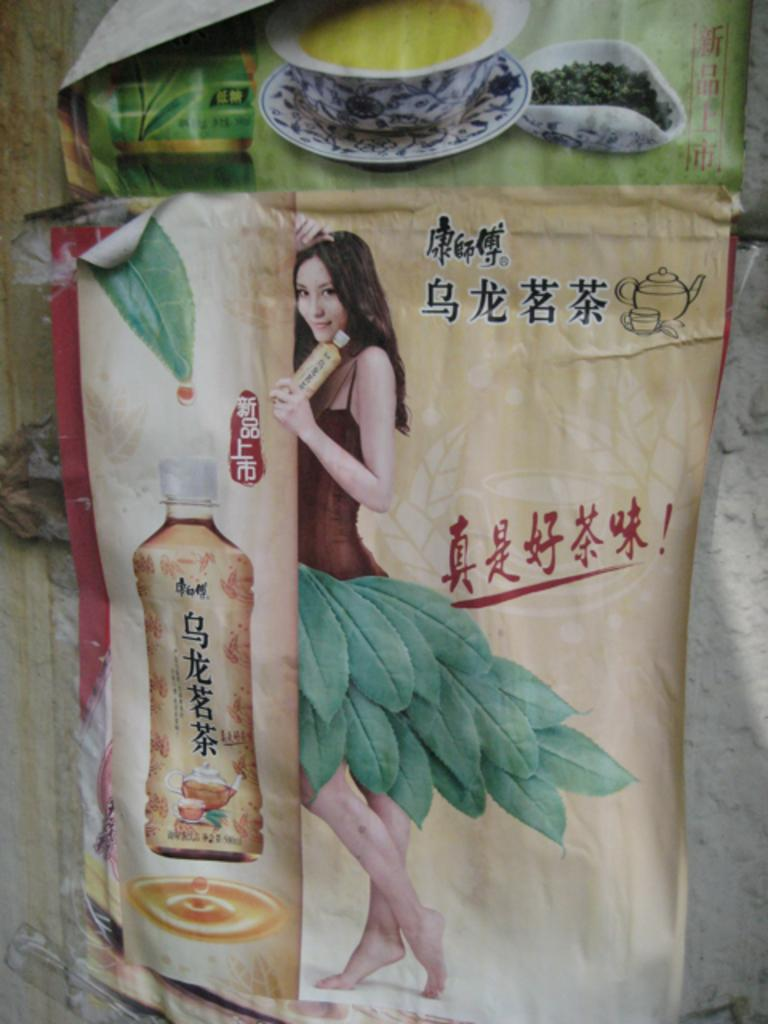What objects can be seen in the image? There are posts in the image. Where are the posts located? The posts are placed on a wall. How many geese are sitting on the cork in the image? There are no geese or cork present in the image. 